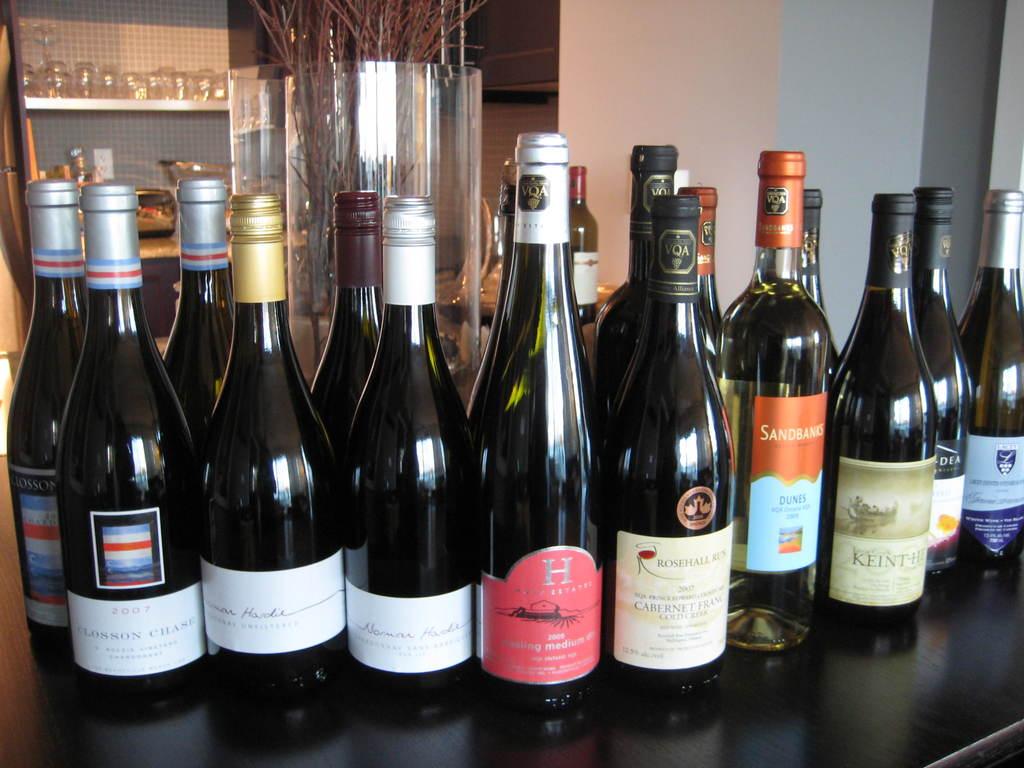What is one of the brands of wine/champagne?
Ensure brevity in your answer.  Sandbanks. 